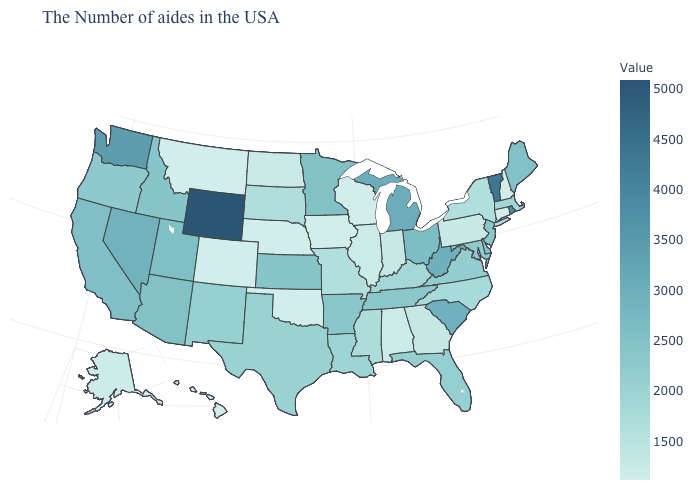Which states have the lowest value in the USA?
Keep it brief. New Hampshire, Connecticut, Wisconsin, Iowa, Nebraska, Oklahoma, Colorado, Montana, Hawaii. Among the states that border Virginia , does Tennessee have the highest value?
Keep it brief. No. Among the states that border Oklahoma , does Missouri have the highest value?
Keep it brief. No. Does Missouri have a higher value than Wyoming?
Concise answer only. No. Does Colorado have the lowest value in the USA?
Answer briefly. Yes. Among the states that border South Dakota , does Minnesota have the lowest value?
Quick response, please. No. Does Massachusetts have the highest value in the Northeast?
Write a very short answer. No. Among the states that border Nevada , does Utah have the highest value?
Answer briefly. Yes. Does Rhode Island have the highest value in the USA?
Short answer required. No. 